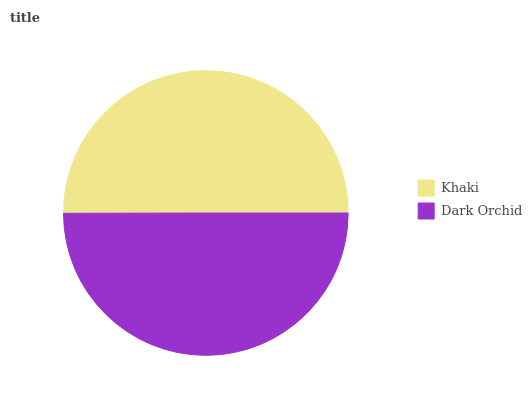Is Dark Orchid the minimum?
Answer yes or no. Yes. Is Khaki the maximum?
Answer yes or no. Yes. Is Dark Orchid the maximum?
Answer yes or no. No. Is Khaki greater than Dark Orchid?
Answer yes or no. Yes. Is Dark Orchid less than Khaki?
Answer yes or no. Yes. Is Dark Orchid greater than Khaki?
Answer yes or no. No. Is Khaki less than Dark Orchid?
Answer yes or no. No. Is Khaki the high median?
Answer yes or no. Yes. Is Dark Orchid the low median?
Answer yes or no. Yes. Is Dark Orchid the high median?
Answer yes or no. No. Is Khaki the low median?
Answer yes or no. No. 